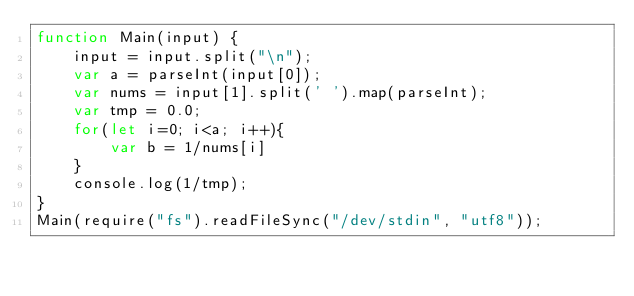Convert code to text. <code><loc_0><loc_0><loc_500><loc_500><_JavaScript_>function Main(input) {
    input = input.split("\n");
    var a = parseInt(input[0]);
    var nums = input[1].split(' ').map(parseInt);
    var tmp = 0.0;
    for(let i=0; i<a; i++){
        var b = 1/nums[i]
    }
    console.log(1/tmp);
}
Main(require("fs").readFileSync("/dev/stdin", "utf8"));
</code> 